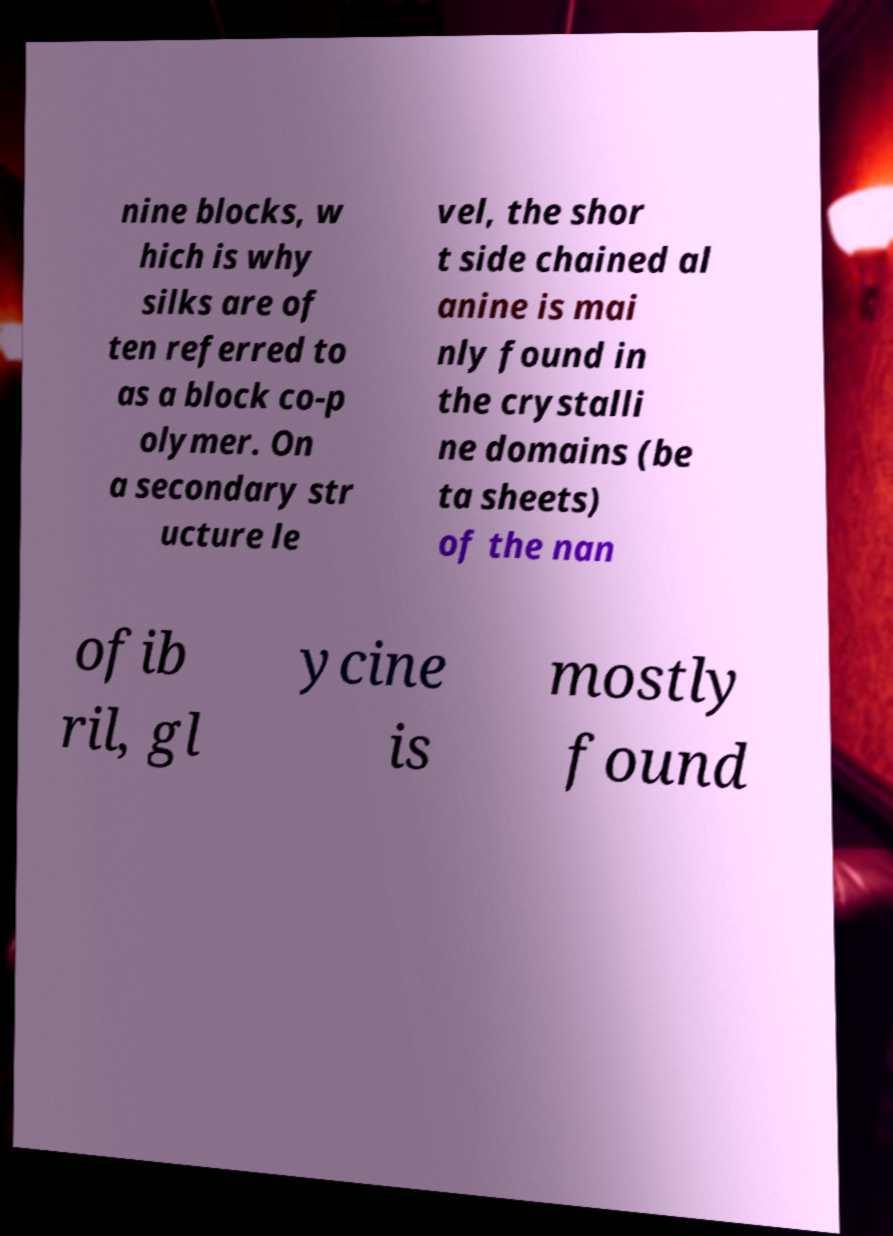I need the written content from this picture converted into text. Can you do that? nine blocks, w hich is why silks are of ten referred to as a block co-p olymer. On a secondary str ucture le vel, the shor t side chained al anine is mai nly found in the crystalli ne domains (be ta sheets) of the nan ofib ril, gl ycine is mostly found 